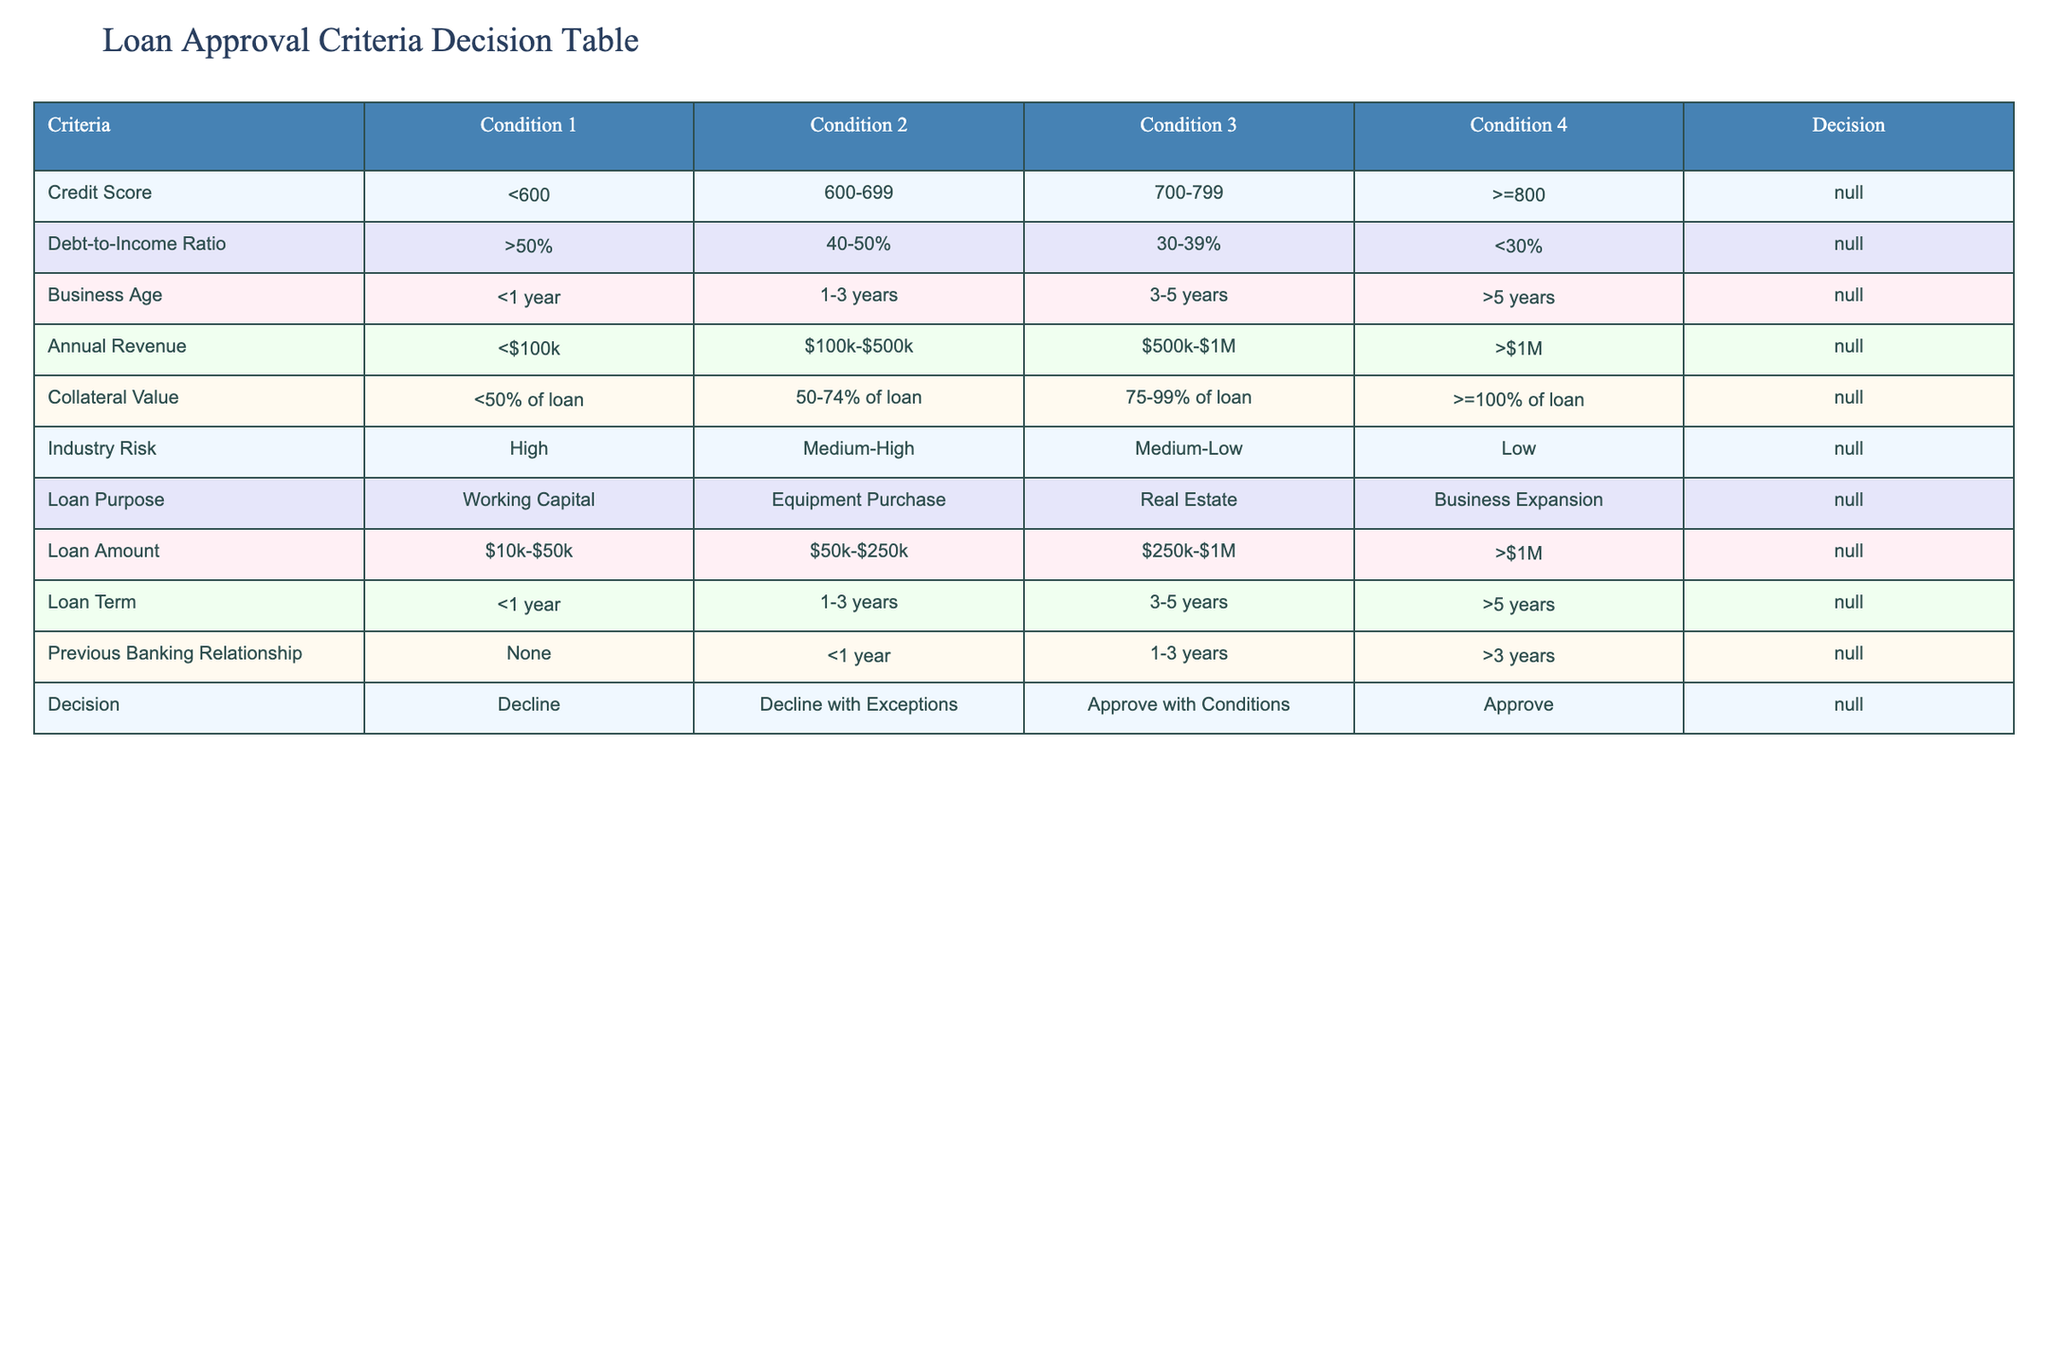What is the decision for a loan applicant with a credit score of 750 and a debt-to-income ratio of 35%? According to the table, a credit score of 750 falls in Condition 3 (700-799), and a debt-to-income ratio of 35% also falls in Condition 3 (30-39%). The decision for both conditions is "Approve with Conditions."
Answer: Approve with Conditions Is a loan with a collateral value of 90% of the loan amount considered? A collateral value of 90% falls under Condition 3 (75-99% of loan) in the Collateral Value row. The decision for this condition is "Approve with Conditions." Therefore, it is indeed considered.
Answer: Yes What is the average annual revenue of applicants who would be approved for loans? Based on the table, to be approved for loans, annual revenue should be greater than $1M (Condition 4). Since there is one value per condition, the average for approved applicants is simply greater than $1M, which cannot be quantified precisely in numerical terms but is the only condition that meets the approval criterion. Thus the average is undefined.
Answer: Undefined If an applicant seeks a loan for business expansion and has high industry risk, what would be the decision? The decision for starting with a business expansion loan is in the Loan Purpose section under "Business Expansion." However, if the industry risk is high (Condition 1 under Industry Risk), this leads to a decision of "Decline." Hence, the applicant seeking this combination would not be approved.
Answer: Decline What would be the loan decision if an applicant has a credit score of 600 and the loan purpose is for real estate? A credit score of 600 falls into Condition 2 (600-699) and the loan purpose of real estate also sits in Condition 3. Combining both criteria generates a decision of "Decline with Exceptions," as both conditions dictate a cautious approach despite the loan purpose's potential.
Answer: Decline with Exceptions 